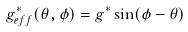<formula> <loc_0><loc_0><loc_500><loc_500>g _ { e f f } ^ { * } ( \theta , \phi ) = g ^ { * } \sin ( \phi - \theta )</formula> 